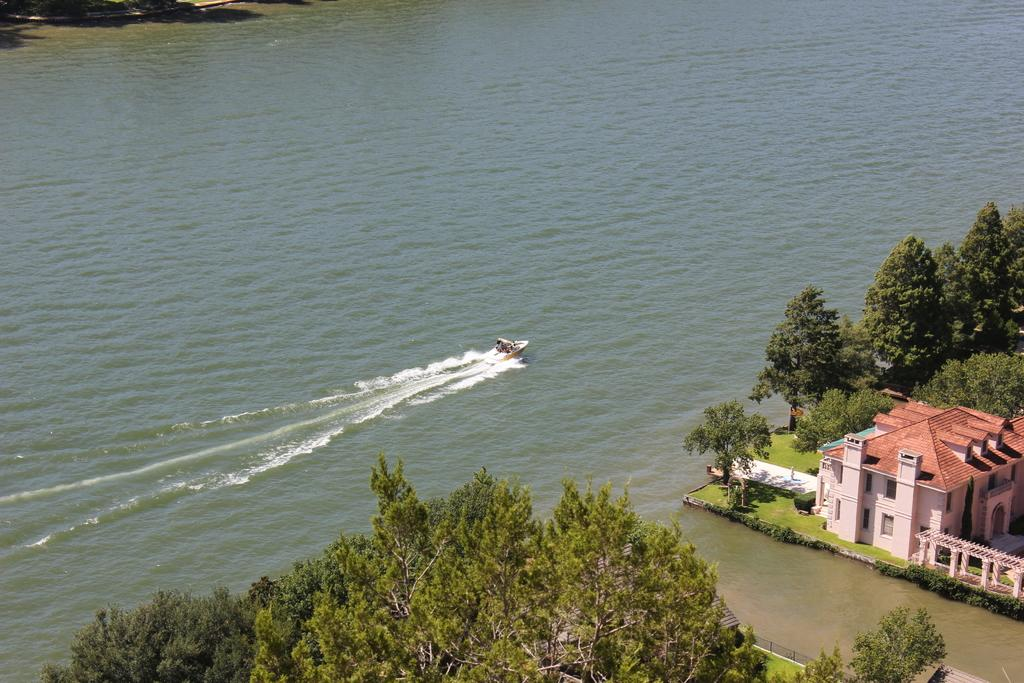What type of view is shown in the image? The image is an aerial view. What natural elements can be seen in the image? There are trees and grass visible in the image. What man-made structures are present in the image? There are houses in the image. Can you describe any objects related to water in the image? A boat is floating on the water in the image. What type of pot is hanging from the tail of the boat in the image? There is no pot or boat with a tail present in the image. 